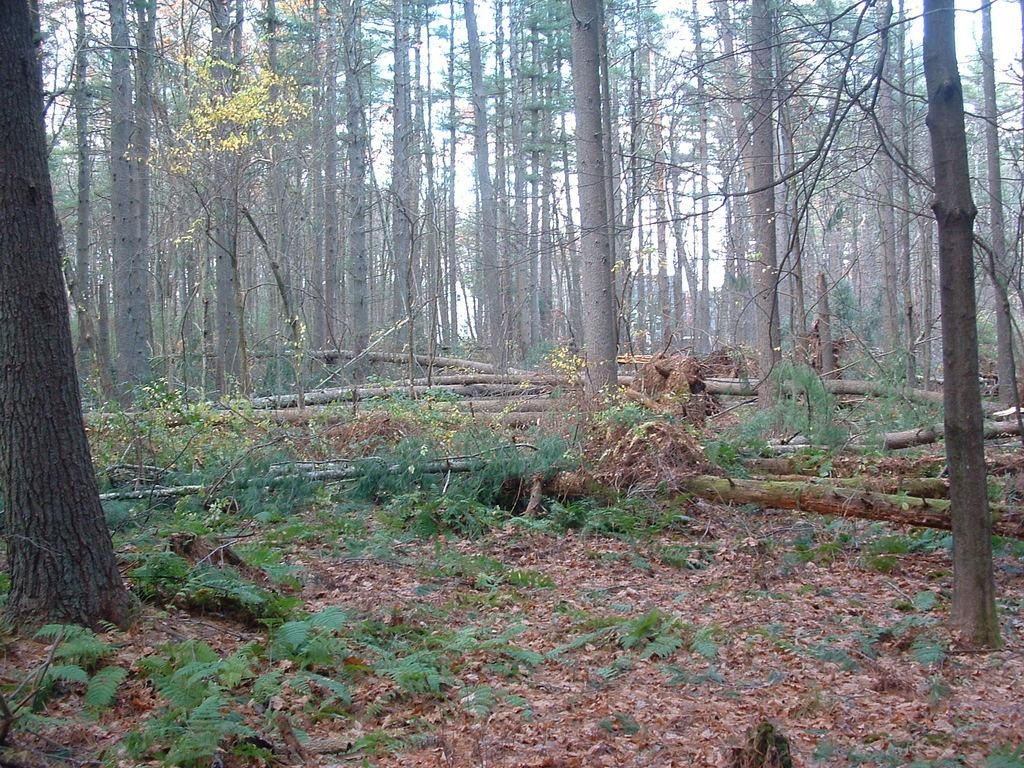What type of vegetation can be seen in the image? There are trees and plants in the image. What is the condition of the leaves on the trees and plants? Dried leaves are present in the image. What part of the natural environment is visible in the image? Some part of the sky is visible in the image. How many rings are visible on the tree in the image? There are no rings visible on the tree in the image, as the provided facts do not mention any rings. Can you describe the grass in the image? There is no grass present in the image; it only features trees, plants, and dried leaves. 